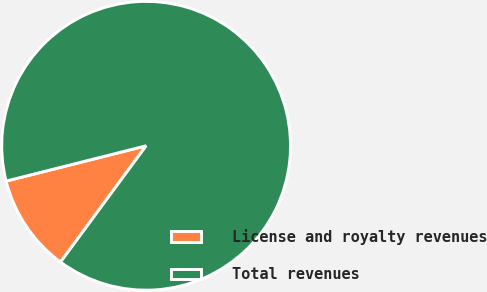<chart> <loc_0><loc_0><loc_500><loc_500><pie_chart><fcel>License and royalty revenues<fcel>Total revenues<nl><fcel>10.97%<fcel>89.03%<nl></chart> 